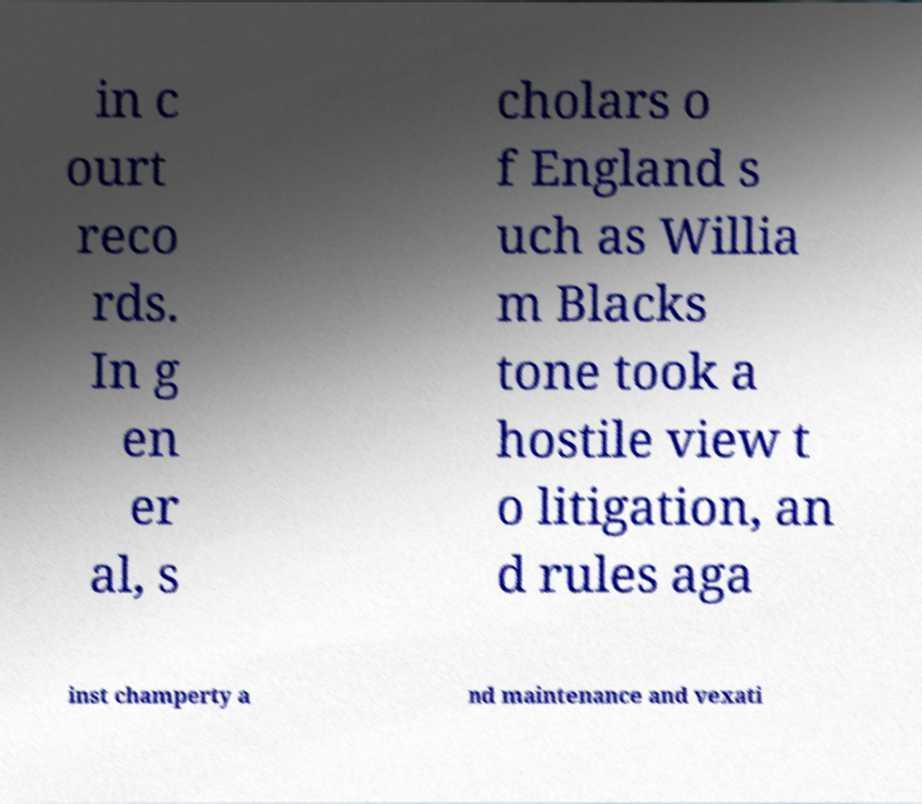Please read and relay the text visible in this image. What does it say? in c ourt reco rds. In g en er al, s cholars o f England s uch as Willia m Blacks tone took a hostile view t o litigation, an d rules aga inst champerty a nd maintenance and vexati 